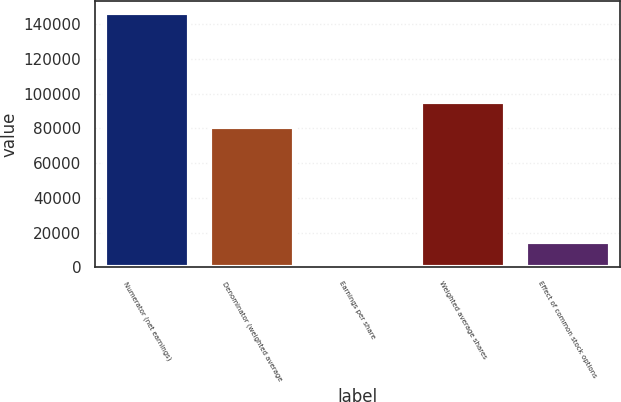<chart> <loc_0><loc_0><loc_500><loc_500><bar_chart><fcel>Numerator (net earnings)<fcel>Denominator (weighted average<fcel>Earnings per share<fcel>Weighted average shares<fcel>Effect of common stock options<nl><fcel>146256<fcel>80771<fcel>1.81<fcel>95396.4<fcel>14627.2<nl></chart> 